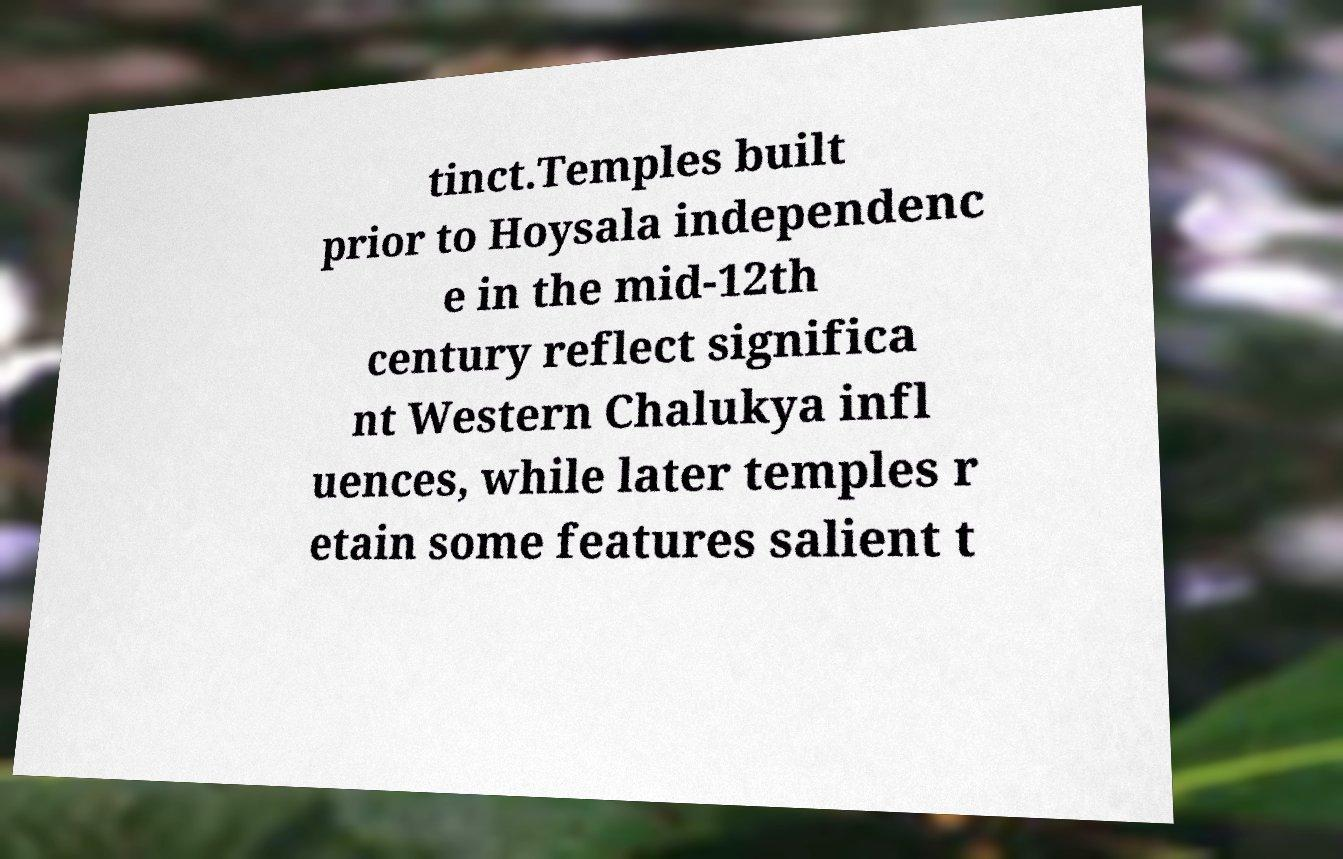Could you assist in decoding the text presented in this image and type it out clearly? tinct.Temples built prior to Hoysala independenc e in the mid-12th century reflect significa nt Western Chalukya infl uences, while later temples r etain some features salient t 